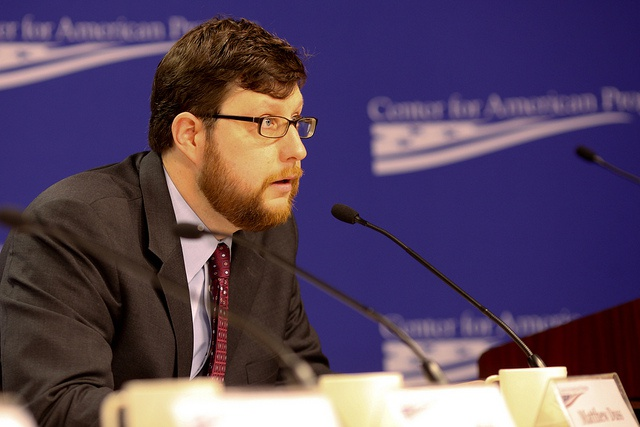Describe the objects in this image and their specific colors. I can see people in navy, black, maroon, and tan tones, cup in navy, khaki, ivory, and tan tones, cup in navy, ivory, khaki, tan, and darkgray tones, cup in navy, khaki, beige, and tan tones, and tie in navy, maroon, black, and brown tones in this image. 